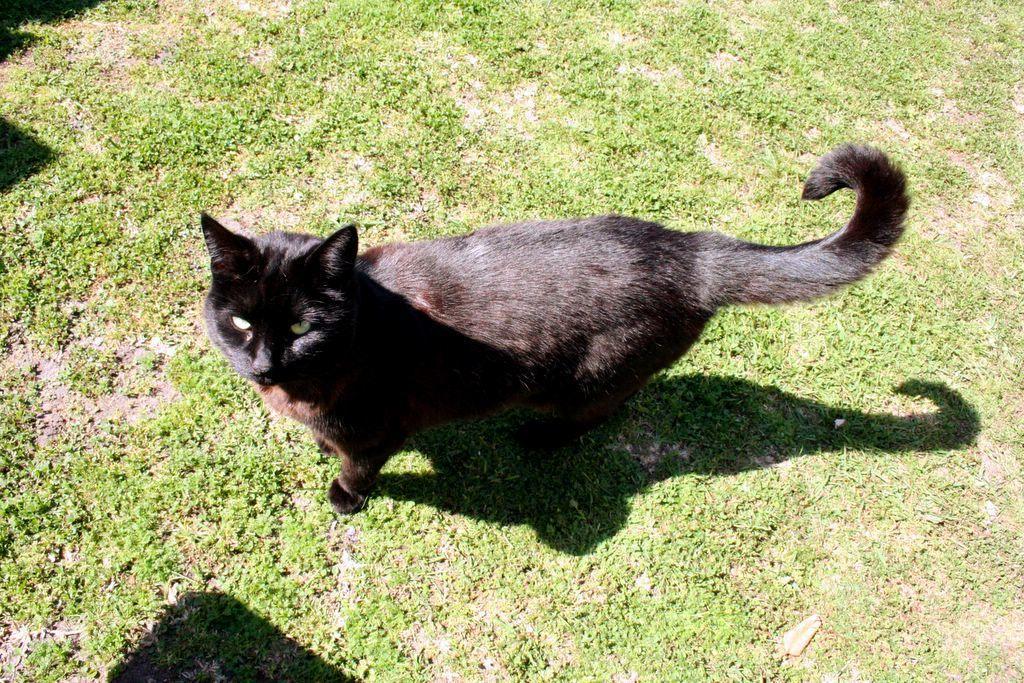Describe this image in one or two sentences. In this image we can see a cat. On the ground there is grass. 